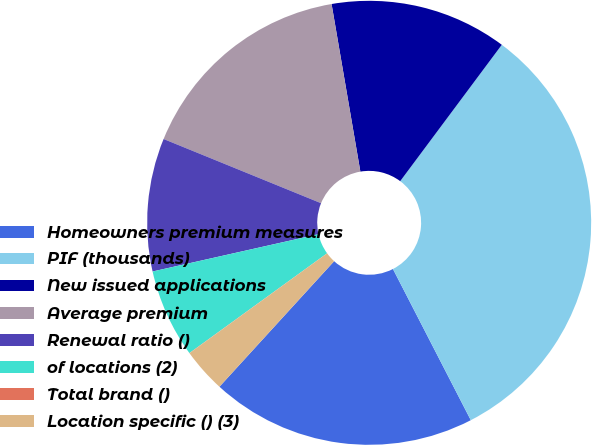Convert chart. <chart><loc_0><loc_0><loc_500><loc_500><pie_chart><fcel>Homeowners premium measures<fcel>PIF (thousands)<fcel>New issued applications<fcel>Average premium<fcel>Renewal ratio ()<fcel>of locations (2)<fcel>Total brand ()<fcel>Location specific () (3)<nl><fcel>19.35%<fcel>32.24%<fcel>12.9%<fcel>16.13%<fcel>9.68%<fcel>6.46%<fcel>0.01%<fcel>3.23%<nl></chart> 